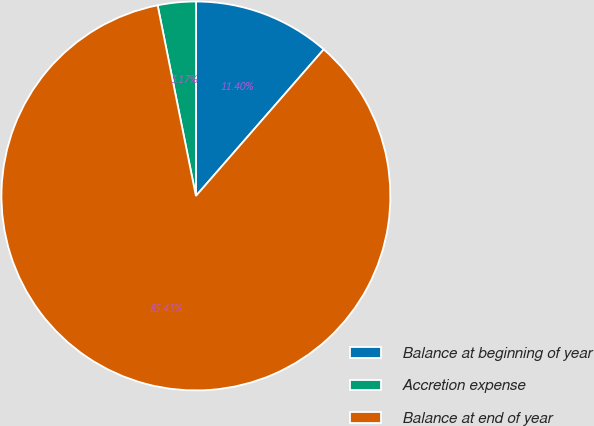<chart> <loc_0><loc_0><loc_500><loc_500><pie_chart><fcel>Balance at beginning of year<fcel>Accretion expense<fcel>Balance at end of year<nl><fcel>11.4%<fcel>3.17%<fcel>85.44%<nl></chart> 